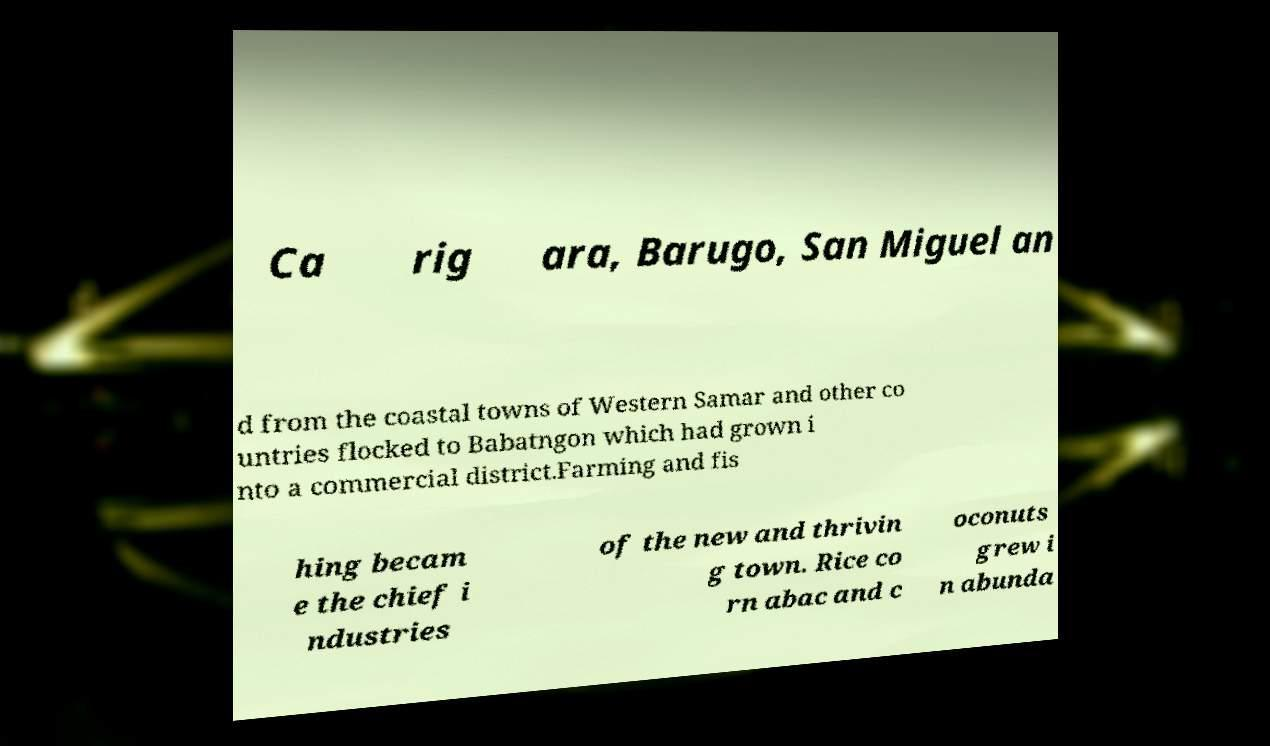For documentation purposes, I need the text within this image transcribed. Could you provide that? Ca rig ara, Barugo, San Miguel an d from the coastal towns of Western Samar and other co untries flocked to Babatngon which had grown i nto a commercial district.Farming and fis hing becam e the chief i ndustries of the new and thrivin g town. Rice co rn abac and c oconuts grew i n abunda 